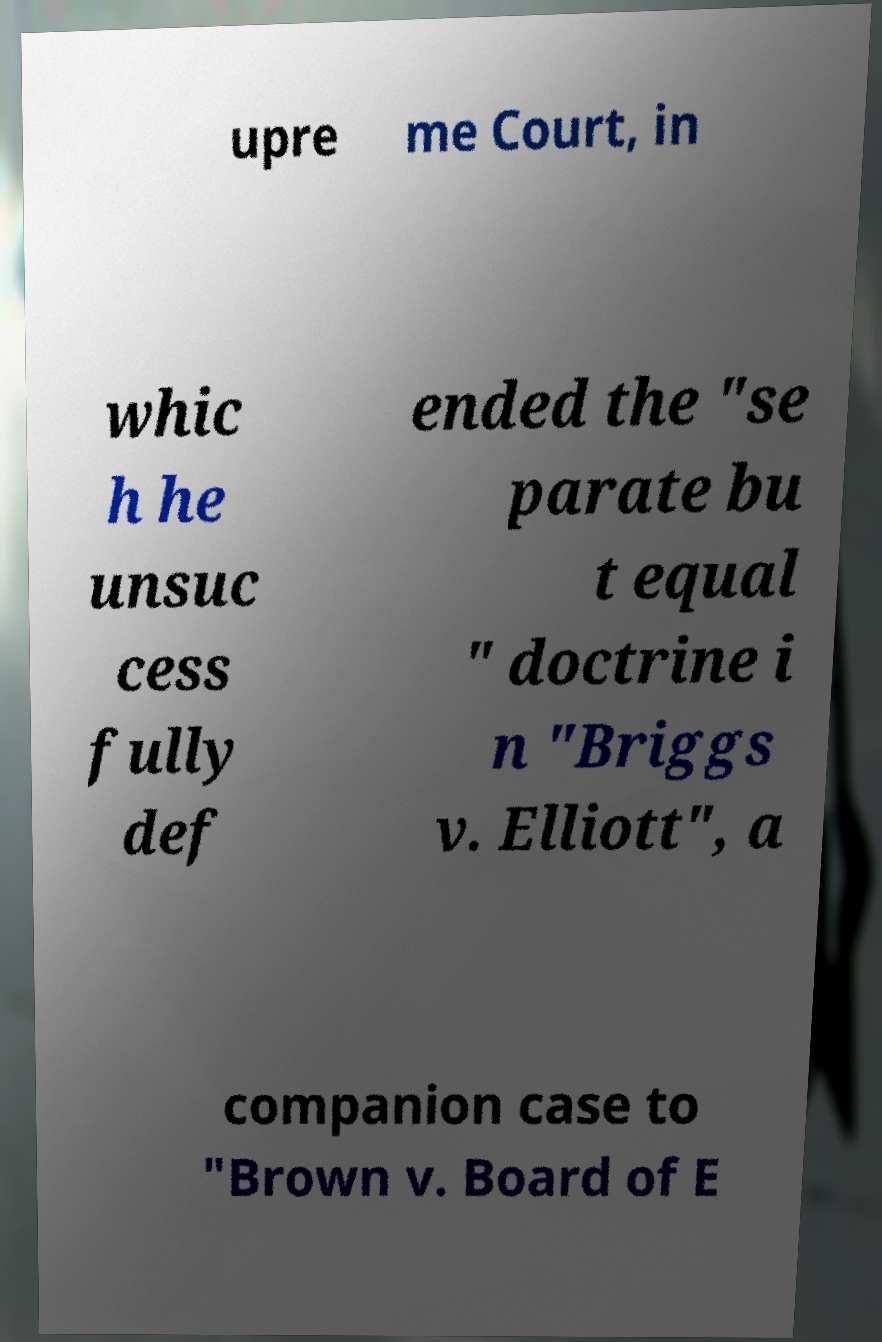Can you accurately transcribe the text from the provided image for me? upre me Court, in whic h he unsuc cess fully def ended the "se parate bu t equal " doctrine i n "Briggs v. Elliott", a companion case to "Brown v. Board of E 